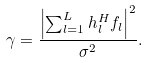Convert formula to latex. <formula><loc_0><loc_0><loc_500><loc_500>\gamma = \frac { { { { \left | { \sum \nolimits _ { l = 1 } ^ { L } { { h } _ { l } ^ { H } { { f } _ { l } } } } \right | } ^ { 2 } } } } { \sigma ^ { 2 } } .</formula> 